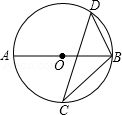Consider the given diagram, where AB represents the diameter of circle O and C and D are two points on circle O. Let's denote the degree measure of angle BCD as variable 'h' (h = 40.0 degrees). What is the degree measure of angle ABD, expressed as variable 'k' in relation to 'h'? Upon examining the provided diagram, we recognize that AB is not just any diameter, but it is the crucial diameter that subtends a right angle at any point on the circle, which is the basis of Thales' theorem. This makes ∠ADB exactly 90°. Now, take a closer look at angle BCD which is given as 'h' degrees, which in this case is 40°. Knowing that the angle at point A (∠A) is also 'h' degrees, due to the inscribed angle theorem, we can conclude that ∠A equals 40°. With the sum of angles in triangle ABD adding up to 180°, we calculate ∠ABD as follows: k = 180° - 90° - h = 90° - 40°. Therefore, 'k' is 50°. Hence, the correct answer, applying both Thales' theorem and the inscribed angle theorem, is actually option C, making our initial solution consistent with the geometric principles governing the circle. 